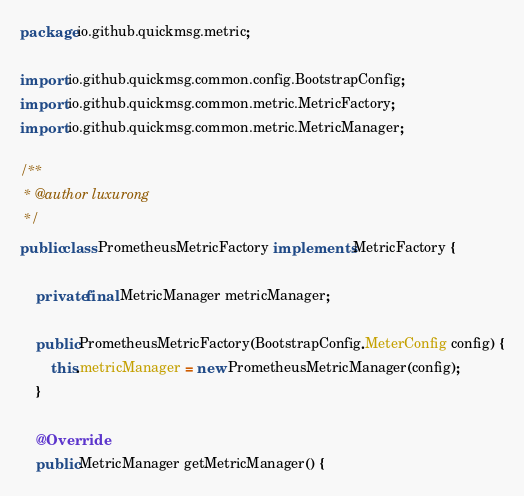<code> <loc_0><loc_0><loc_500><loc_500><_Java_>package io.github.quickmsg.metric;

import io.github.quickmsg.common.config.BootstrapConfig;
import io.github.quickmsg.common.metric.MetricFactory;
import io.github.quickmsg.common.metric.MetricManager;

/**
 * @author luxurong
 */
public class PrometheusMetricFactory implements MetricFactory {

    private final MetricManager metricManager;

    public PrometheusMetricFactory(BootstrapConfig.MeterConfig config) {
        this.metricManager = new PrometheusMetricManager(config);
    }

    @Override
    public MetricManager getMetricManager() {</code> 